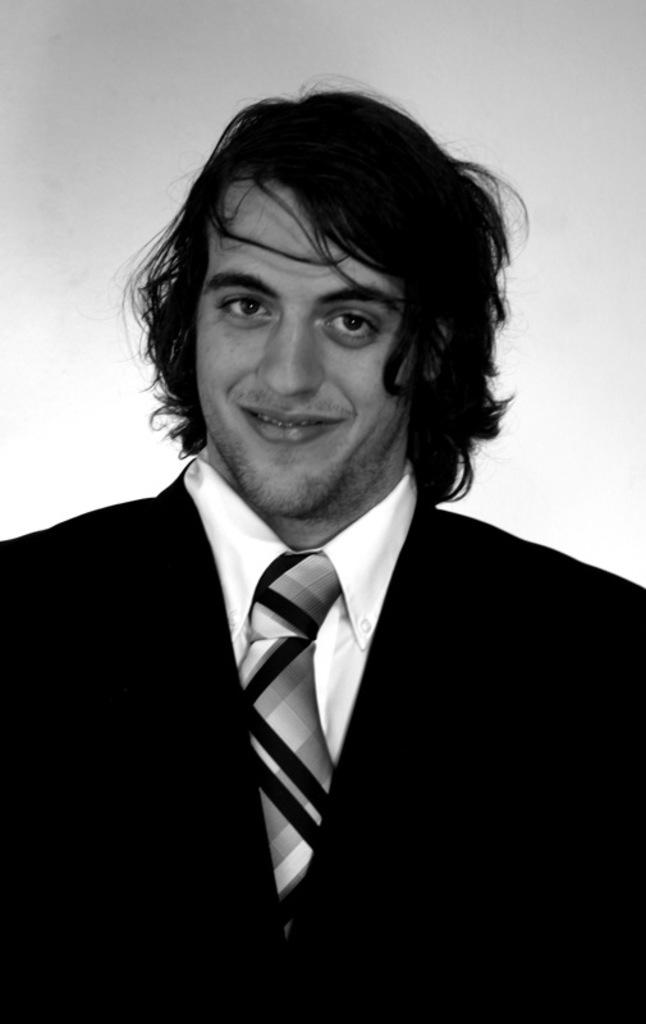Who is present in the image? There is a man in the image. What is the man's facial expression? The man is smiling. What color is the background of the image? The background of the image is white. What type of cakes can be seen in the image? There are no cakes present in the image; it features a man with a white background. 